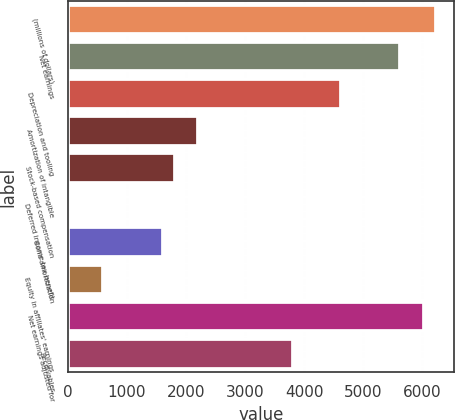Convert chart. <chart><loc_0><loc_0><loc_500><loc_500><bar_chart><fcel>(millions of dollars)<fcel>Net earnings<fcel>Depreciation and tooling<fcel>Amortization of intangible<fcel>Stock-based compensation<fcel>Deferred income tax benefit<fcel>Bond amortization<fcel>Equity in affiliates' earnings<fcel>Net earnings adjusted for<fcel>Receivables<nl><fcel>6231.79<fcel>5628.82<fcel>4623.87<fcel>2211.99<fcel>1810.01<fcel>1.1<fcel>1609.02<fcel>604.07<fcel>6030.8<fcel>3819.91<nl></chart> 